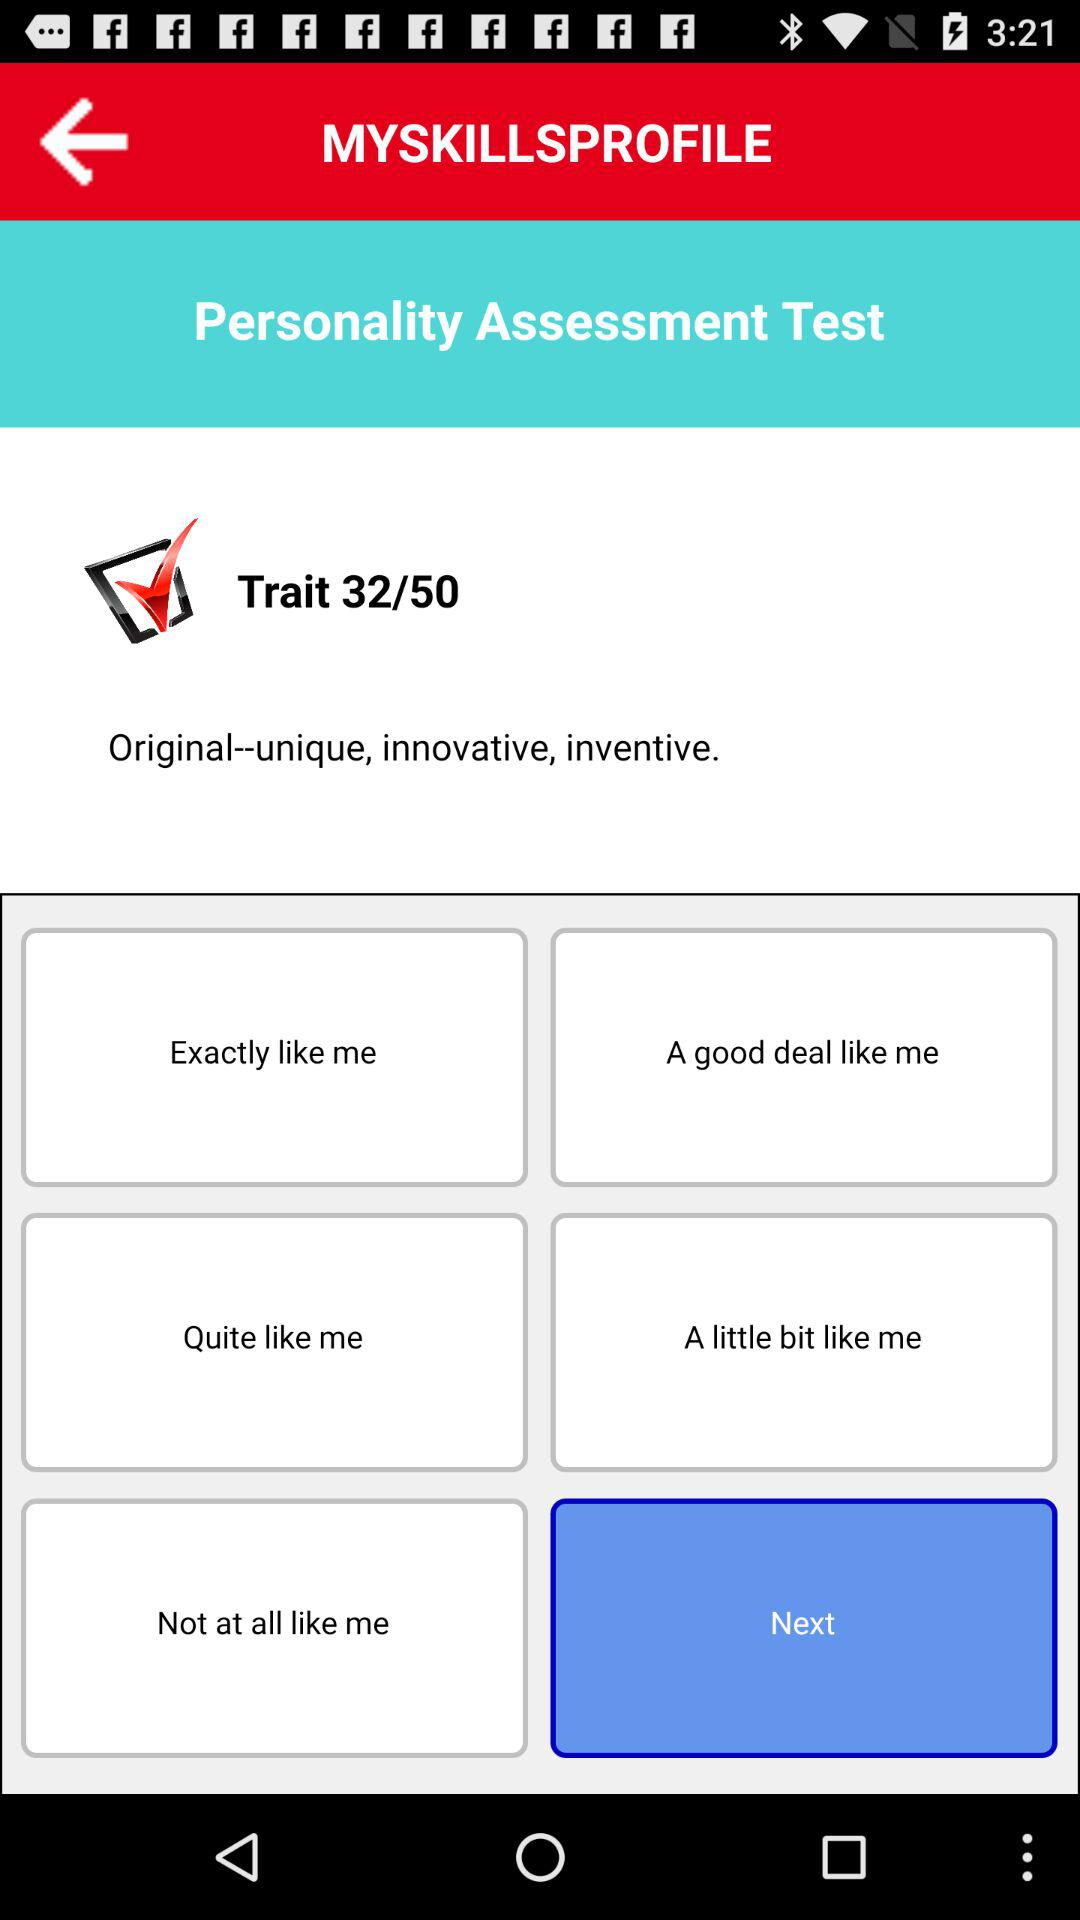What is the total number of traits? The total number of traits is 50. 